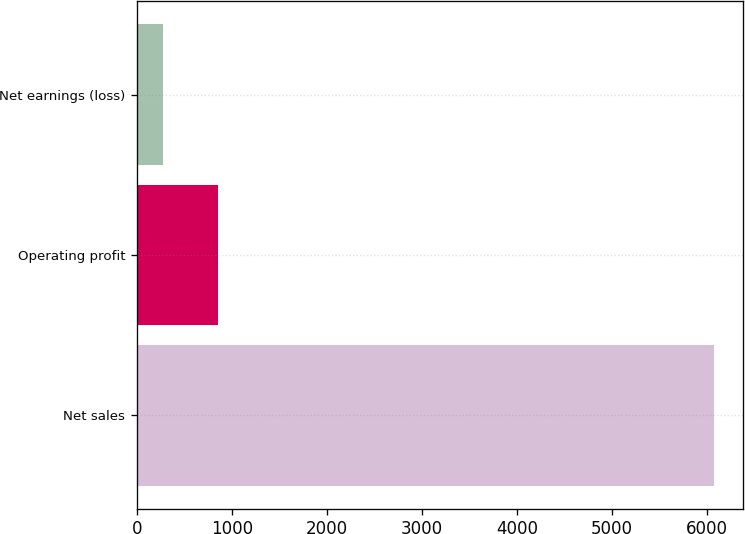Convert chart. <chart><loc_0><loc_0><loc_500><loc_500><bar_chart><fcel>Net sales<fcel>Operating profit<fcel>Net earnings (loss)<nl><fcel>6070<fcel>851.8<fcel>272<nl></chart> 